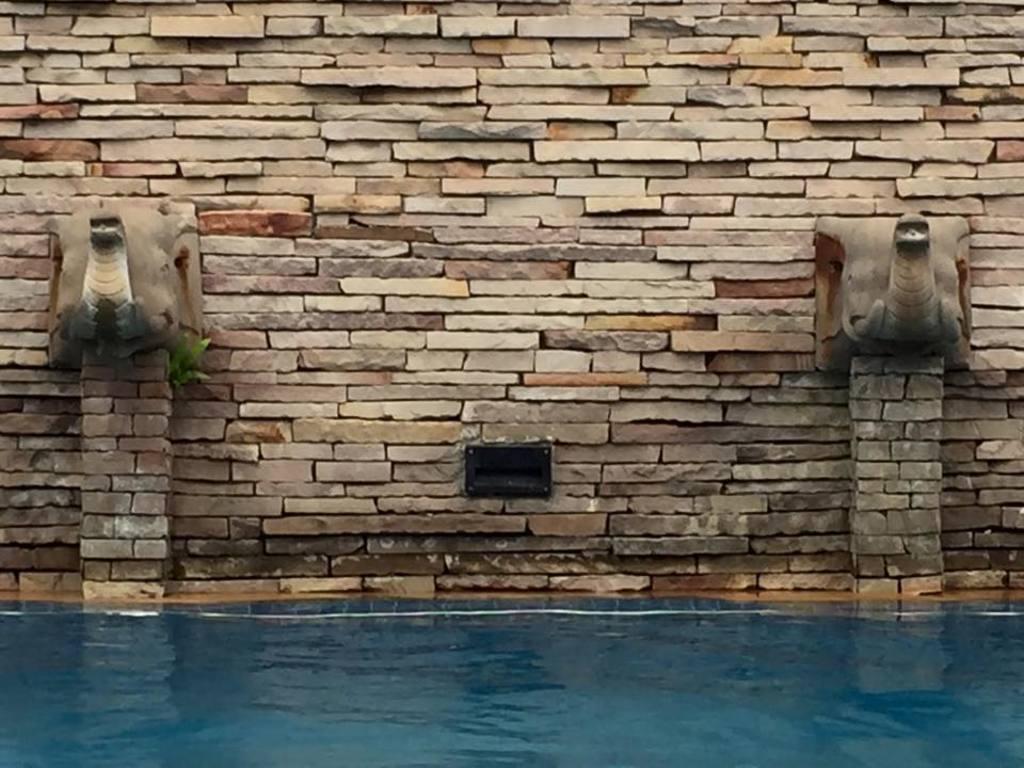Please provide a concise description of this image. In this image we can see water, fountains and wall. 